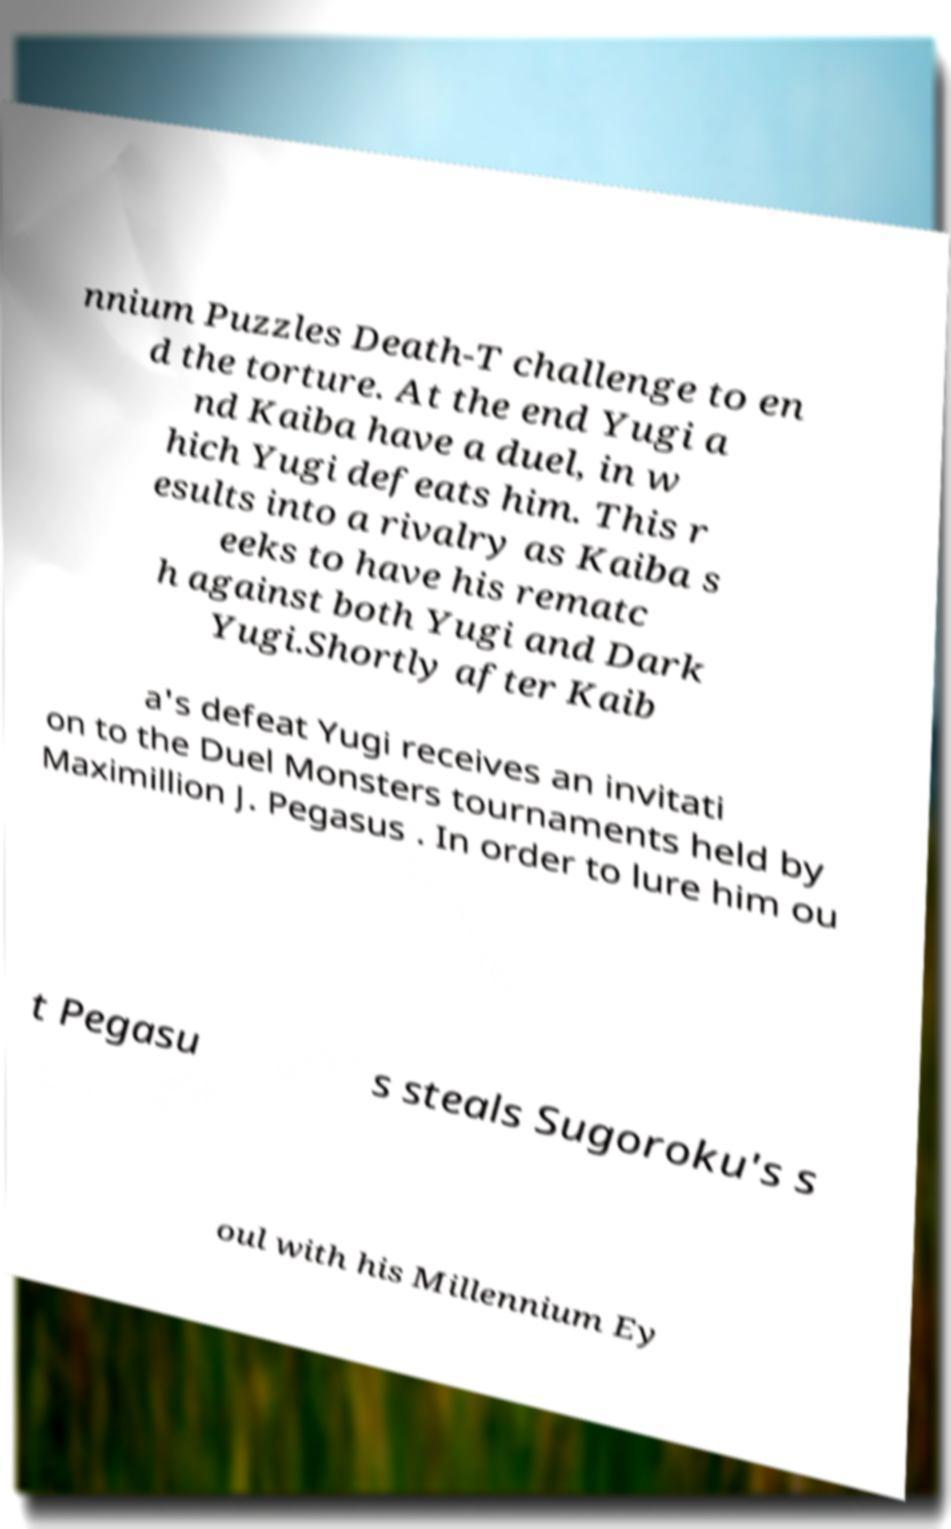Please identify and transcribe the text found in this image. nnium Puzzles Death-T challenge to en d the torture. At the end Yugi a nd Kaiba have a duel, in w hich Yugi defeats him. This r esults into a rivalry as Kaiba s eeks to have his rematc h against both Yugi and Dark Yugi.Shortly after Kaib a's defeat Yugi receives an invitati on to the Duel Monsters tournaments held by Maximillion J. Pegasus . In order to lure him ou t Pegasu s steals Sugoroku's s oul with his Millennium Ey 